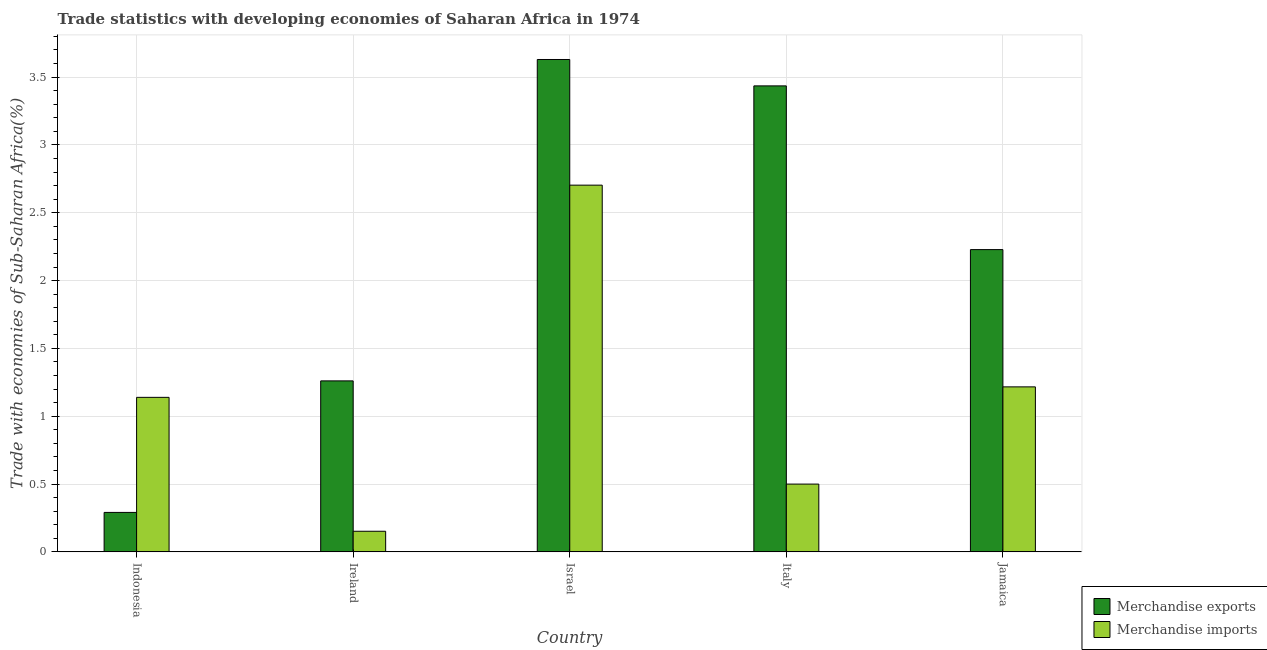How many different coloured bars are there?
Provide a short and direct response. 2. Are the number of bars per tick equal to the number of legend labels?
Keep it short and to the point. Yes. Are the number of bars on each tick of the X-axis equal?
Your answer should be very brief. Yes. How many bars are there on the 5th tick from the left?
Ensure brevity in your answer.  2. What is the label of the 5th group of bars from the left?
Your response must be concise. Jamaica. What is the merchandise imports in Ireland?
Your answer should be compact. 0.15. Across all countries, what is the maximum merchandise imports?
Provide a short and direct response. 2.7. Across all countries, what is the minimum merchandise exports?
Your answer should be compact. 0.29. In which country was the merchandise imports maximum?
Keep it short and to the point. Israel. What is the total merchandise exports in the graph?
Make the answer very short. 10.85. What is the difference between the merchandise exports in Indonesia and that in Jamaica?
Your response must be concise. -1.94. What is the difference between the merchandise exports in Israel and the merchandise imports in Ireland?
Your response must be concise. 3.48. What is the average merchandise imports per country?
Ensure brevity in your answer.  1.14. What is the difference between the merchandise exports and merchandise imports in Israel?
Make the answer very short. 0.93. What is the ratio of the merchandise exports in Ireland to that in Jamaica?
Provide a succinct answer. 0.57. Is the merchandise exports in Israel less than that in Jamaica?
Provide a succinct answer. No. Is the difference between the merchandise exports in Indonesia and Italy greater than the difference between the merchandise imports in Indonesia and Italy?
Keep it short and to the point. No. What is the difference between the highest and the second highest merchandise imports?
Make the answer very short. 1.49. What is the difference between the highest and the lowest merchandise imports?
Offer a very short reply. 2.55. In how many countries, is the merchandise exports greater than the average merchandise exports taken over all countries?
Offer a very short reply. 3. Is the sum of the merchandise imports in Indonesia and Ireland greater than the maximum merchandise exports across all countries?
Keep it short and to the point. No. What does the 2nd bar from the left in Jamaica represents?
Keep it short and to the point. Merchandise imports. What does the 2nd bar from the right in Jamaica represents?
Ensure brevity in your answer.  Merchandise exports. How many countries are there in the graph?
Offer a terse response. 5. What is the difference between two consecutive major ticks on the Y-axis?
Offer a very short reply. 0.5. Are the values on the major ticks of Y-axis written in scientific E-notation?
Offer a very short reply. No. Where does the legend appear in the graph?
Offer a terse response. Bottom right. How are the legend labels stacked?
Make the answer very short. Vertical. What is the title of the graph?
Make the answer very short. Trade statistics with developing economies of Saharan Africa in 1974. Does "Male labor force" appear as one of the legend labels in the graph?
Make the answer very short. No. What is the label or title of the X-axis?
Provide a succinct answer. Country. What is the label or title of the Y-axis?
Provide a succinct answer. Trade with economies of Sub-Saharan Africa(%). What is the Trade with economies of Sub-Saharan Africa(%) of Merchandise exports in Indonesia?
Your answer should be compact. 0.29. What is the Trade with economies of Sub-Saharan Africa(%) of Merchandise imports in Indonesia?
Give a very brief answer. 1.14. What is the Trade with economies of Sub-Saharan Africa(%) of Merchandise exports in Ireland?
Provide a short and direct response. 1.26. What is the Trade with economies of Sub-Saharan Africa(%) of Merchandise imports in Ireland?
Offer a very short reply. 0.15. What is the Trade with economies of Sub-Saharan Africa(%) in Merchandise exports in Israel?
Offer a terse response. 3.63. What is the Trade with economies of Sub-Saharan Africa(%) of Merchandise imports in Israel?
Ensure brevity in your answer.  2.7. What is the Trade with economies of Sub-Saharan Africa(%) of Merchandise exports in Italy?
Your answer should be very brief. 3.44. What is the Trade with economies of Sub-Saharan Africa(%) of Merchandise imports in Italy?
Keep it short and to the point. 0.5. What is the Trade with economies of Sub-Saharan Africa(%) of Merchandise exports in Jamaica?
Offer a terse response. 2.23. What is the Trade with economies of Sub-Saharan Africa(%) of Merchandise imports in Jamaica?
Keep it short and to the point. 1.22. Across all countries, what is the maximum Trade with economies of Sub-Saharan Africa(%) in Merchandise exports?
Offer a terse response. 3.63. Across all countries, what is the maximum Trade with economies of Sub-Saharan Africa(%) in Merchandise imports?
Offer a terse response. 2.7. Across all countries, what is the minimum Trade with economies of Sub-Saharan Africa(%) in Merchandise exports?
Ensure brevity in your answer.  0.29. Across all countries, what is the minimum Trade with economies of Sub-Saharan Africa(%) in Merchandise imports?
Keep it short and to the point. 0.15. What is the total Trade with economies of Sub-Saharan Africa(%) in Merchandise exports in the graph?
Offer a terse response. 10.85. What is the total Trade with economies of Sub-Saharan Africa(%) of Merchandise imports in the graph?
Offer a terse response. 5.71. What is the difference between the Trade with economies of Sub-Saharan Africa(%) of Merchandise exports in Indonesia and that in Ireland?
Provide a succinct answer. -0.97. What is the difference between the Trade with economies of Sub-Saharan Africa(%) of Merchandise imports in Indonesia and that in Ireland?
Your answer should be compact. 0.99. What is the difference between the Trade with economies of Sub-Saharan Africa(%) in Merchandise exports in Indonesia and that in Israel?
Keep it short and to the point. -3.34. What is the difference between the Trade with economies of Sub-Saharan Africa(%) in Merchandise imports in Indonesia and that in Israel?
Ensure brevity in your answer.  -1.56. What is the difference between the Trade with economies of Sub-Saharan Africa(%) in Merchandise exports in Indonesia and that in Italy?
Offer a terse response. -3.14. What is the difference between the Trade with economies of Sub-Saharan Africa(%) in Merchandise imports in Indonesia and that in Italy?
Your answer should be compact. 0.64. What is the difference between the Trade with economies of Sub-Saharan Africa(%) of Merchandise exports in Indonesia and that in Jamaica?
Provide a succinct answer. -1.94. What is the difference between the Trade with economies of Sub-Saharan Africa(%) in Merchandise imports in Indonesia and that in Jamaica?
Offer a terse response. -0.08. What is the difference between the Trade with economies of Sub-Saharan Africa(%) of Merchandise exports in Ireland and that in Israel?
Offer a terse response. -2.37. What is the difference between the Trade with economies of Sub-Saharan Africa(%) in Merchandise imports in Ireland and that in Israel?
Your response must be concise. -2.55. What is the difference between the Trade with economies of Sub-Saharan Africa(%) of Merchandise exports in Ireland and that in Italy?
Offer a terse response. -2.17. What is the difference between the Trade with economies of Sub-Saharan Africa(%) in Merchandise imports in Ireland and that in Italy?
Make the answer very short. -0.35. What is the difference between the Trade with economies of Sub-Saharan Africa(%) of Merchandise exports in Ireland and that in Jamaica?
Your response must be concise. -0.97. What is the difference between the Trade with economies of Sub-Saharan Africa(%) of Merchandise imports in Ireland and that in Jamaica?
Offer a terse response. -1.06. What is the difference between the Trade with economies of Sub-Saharan Africa(%) in Merchandise exports in Israel and that in Italy?
Make the answer very short. 0.19. What is the difference between the Trade with economies of Sub-Saharan Africa(%) in Merchandise imports in Israel and that in Italy?
Offer a terse response. 2.2. What is the difference between the Trade with economies of Sub-Saharan Africa(%) in Merchandise exports in Israel and that in Jamaica?
Your response must be concise. 1.4. What is the difference between the Trade with economies of Sub-Saharan Africa(%) in Merchandise imports in Israel and that in Jamaica?
Keep it short and to the point. 1.49. What is the difference between the Trade with economies of Sub-Saharan Africa(%) in Merchandise exports in Italy and that in Jamaica?
Offer a terse response. 1.21. What is the difference between the Trade with economies of Sub-Saharan Africa(%) in Merchandise imports in Italy and that in Jamaica?
Provide a short and direct response. -0.72. What is the difference between the Trade with economies of Sub-Saharan Africa(%) in Merchandise exports in Indonesia and the Trade with economies of Sub-Saharan Africa(%) in Merchandise imports in Ireland?
Your response must be concise. 0.14. What is the difference between the Trade with economies of Sub-Saharan Africa(%) of Merchandise exports in Indonesia and the Trade with economies of Sub-Saharan Africa(%) of Merchandise imports in Israel?
Provide a short and direct response. -2.41. What is the difference between the Trade with economies of Sub-Saharan Africa(%) in Merchandise exports in Indonesia and the Trade with economies of Sub-Saharan Africa(%) in Merchandise imports in Italy?
Give a very brief answer. -0.21. What is the difference between the Trade with economies of Sub-Saharan Africa(%) in Merchandise exports in Indonesia and the Trade with economies of Sub-Saharan Africa(%) in Merchandise imports in Jamaica?
Ensure brevity in your answer.  -0.93. What is the difference between the Trade with economies of Sub-Saharan Africa(%) of Merchandise exports in Ireland and the Trade with economies of Sub-Saharan Africa(%) of Merchandise imports in Israel?
Provide a succinct answer. -1.44. What is the difference between the Trade with economies of Sub-Saharan Africa(%) of Merchandise exports in Ireland and the Trade with economies of Sub-Saharan Africa(%) of Merchandise imports in Italy?
Keep it short and to the point. 0.76. What is the difference between the Trade with economies of Sub-Saharan Africa(%) in Merchandise exports in Ireland and the Trade with economies of Sub-Saharan Africa(%) in Merchandise imports in Jamaica?
Your answer should be very brief. 0.04. What is the difference between the Trade with economies of Sub-Saharan Africa(%) of Merchandise exports in Israel and the Trade with economies of Sub-Saharan Africa(%) of Merchandise imports in Italy?
Provide a succinct answer. 3.13. What is the difference between the Trade with economies of Sub-Saharan Africa(%) in Merchandise exports in Israel and the Trade with economies of Sub-Saharan Africa(%) in Merchandise imports in Jamaica?
Provide a succinct answer. 2.41. What is the difference between the Trade with economies of Sub-Saharan Africa(%) in Merchandise exports in Italy and the Trade with economies of Sub-Saharan Africa(%) in Merchandise imports in Jamaica?
Provide a short and direct response. 2.22. What is the average Trade with economies of Sub-Saharan Africa(%) of Merchandise exports per country?
Make the answer very short. 2.17. What is the average Trade with economies of Sub-Saharan Africa(%) of Merchandise imports per country?
Offer a very short reply. 1.14. What is the difference between the Trade with economies of Sub-Saharan Africa(%) in Merchandise exports and Trade with economies of Sub-Saharan Africa(%) in Merchandise imports in Indonesia?
Ensure brevity in your answer.  -0.85. What is the difference between the Trade with economies of Sub-Saharan Africa(%) of Merchandise exports and Trade with economies of Sub-Saharan Africa(%) of Merchandise imports in Ireland?
Keep it short and to the point. 1.11. What is the difference between the Trade with economies of Sub-Saharan Africa(%) of Merchandise exports and Trade with economies of Sub-Saharan Africa(%) of Merchandise imports in Israel?
Your answer should be very brief. 0.93. What is the difference between the Trade with economies of Sub-Saharan Africa(%) of Merchandise exports and Trade with economies of Sub-Saharan Africa(%) of Merchandise imports in Italy?
Your response must be concise. 2.94. What is the ratio of the Trade with economies of Sub-Saharan Africa(%) in Merchandise exports in Indonesia to that in Ireland?
Provide a succinct answer. 0.23. What is the ratio of the Trade with economies of Sub-Saharan Africa(%) of Merchandise imports in Indonesia to that in Ireland?
Provide a succinct answer. 7.49. What is the ratio of the Trade with economies of Sub-Saharan Africa(%) in Merchandise exports in Indonesia to that in Israel?
Your answer should be very brief. 0.08. What is the ratio of the Trade with economies of Sub-Saharan Africa(%) in Merchandise imports in Indonesia to that in Israel?
Your response must be concise. 0.42. What is the ratio of the Trade with economies of Sub-Saharan Africa(%) in Merchandise exports in Indonesia to that in Italy?
Keep it short and to the point. 0.08. What is the ratio of the Trade with economies of Sub-Saharan Africa(%) of Merchandise imports in Indonesia to that in Italy?
Provide a short and direct response. 2.28. What is the ratio of the Trade with economies of Sub-Saharan Africa(%) of Merchandise exports in Indonesia to that in Jamaica?
Keep it short and to the point. 0.13. What is the ratio of the Trade with economies of Sub-Saharan Africa(%) in Merchandise imports in Indonesia to that in Jamaica?
Keep it short and to the point. 0.94. What is the ratio of the Trade with economies of Sub-Saharan Africa(%) of Merchandise exports in Ireland to that in Israel?
Make the answer very short. 0.35. What is the ratio of the Trade with economies of Sub-Saharan Africa(%) of Merchandise imports in Ireland to that in Israel?
Offer a very short reply. 0.06. What is the ratio of the Trade with economies of Sub-Saharan Africa(%) of Merchandise exports in Ireland to that in Italy?
Your answer should be very brief. 0.37. What is the ratio of the Trade with economies of Sub-Saharan Africa(%) in Merchandise imports in Ireland to that in Italy?
Your response must be concise. 0.3. What is the ratio of the Trade with economies of Sub-Saharan Africa(%) of Merchandise exports in Ireland to that in Jamaica?
Your answer should be compact. 0.57. What is the ratio of the Trade with economies of Sub-Saharan Africa(%) in Merchandise imports in Ireland to that in Jamaica?
Ensure brevity in your answer.  0.12. What is the ratio of the Trade with economies of Sub-Saharan Africa(%) of Merchandise exports in Israel to that in Italy?
Offer a very short reply. 1.06. What is the ratio of the Trade with economies of Sub-Saharan Africa(%) in Merchandise imports in Israel to that in Italy?
Ensure brevity in your answer.  5.41. What is the ratio of the Trade with economies of Sub-Saharan Africa(%) of Merchandise exports in Israel to that in Jamaica?
Provide a succinct answer. 1.63. What is the ratio of the Trade with economies of Sub-Saharan Africa(%) in Merchandise imports in Israel to that in Jamaica?
Offer a terse response. 2.22. What is the ratio of the Trade with economies of Sub-Saharan Africa(%) in Merchandise exports in Italy to that in Jamaica?
Offer a very short reply. 1.54. What is the ratio of the Trade with economies of Sub-Saharan Africa(%) of Merchandise imports in Italy to that in Jamaica?
Give a very brief answer. 0.41. What is the difference between the highest and the second highest Trade with economies of Sub-Saharan Africa(%) of Merchandise exports?
Your answer should be compact. 0.19. What is the difference between the highest and the second highest Trade with economies of Sub-Saharan Africa(%) of Merchandise imports?
Your response must be concise. 1.49. What is the difference between the highest and the lowest Trade with economies of Sub-Saharan Africa(%) of Merchandise exports?
Make the answer very short. 3.34. What is the difference between the highest and the lowest Trade with economies of Sub-Saharan Africa(%) of Merchandise imports?
Your answer should be very brief. 2.55. 